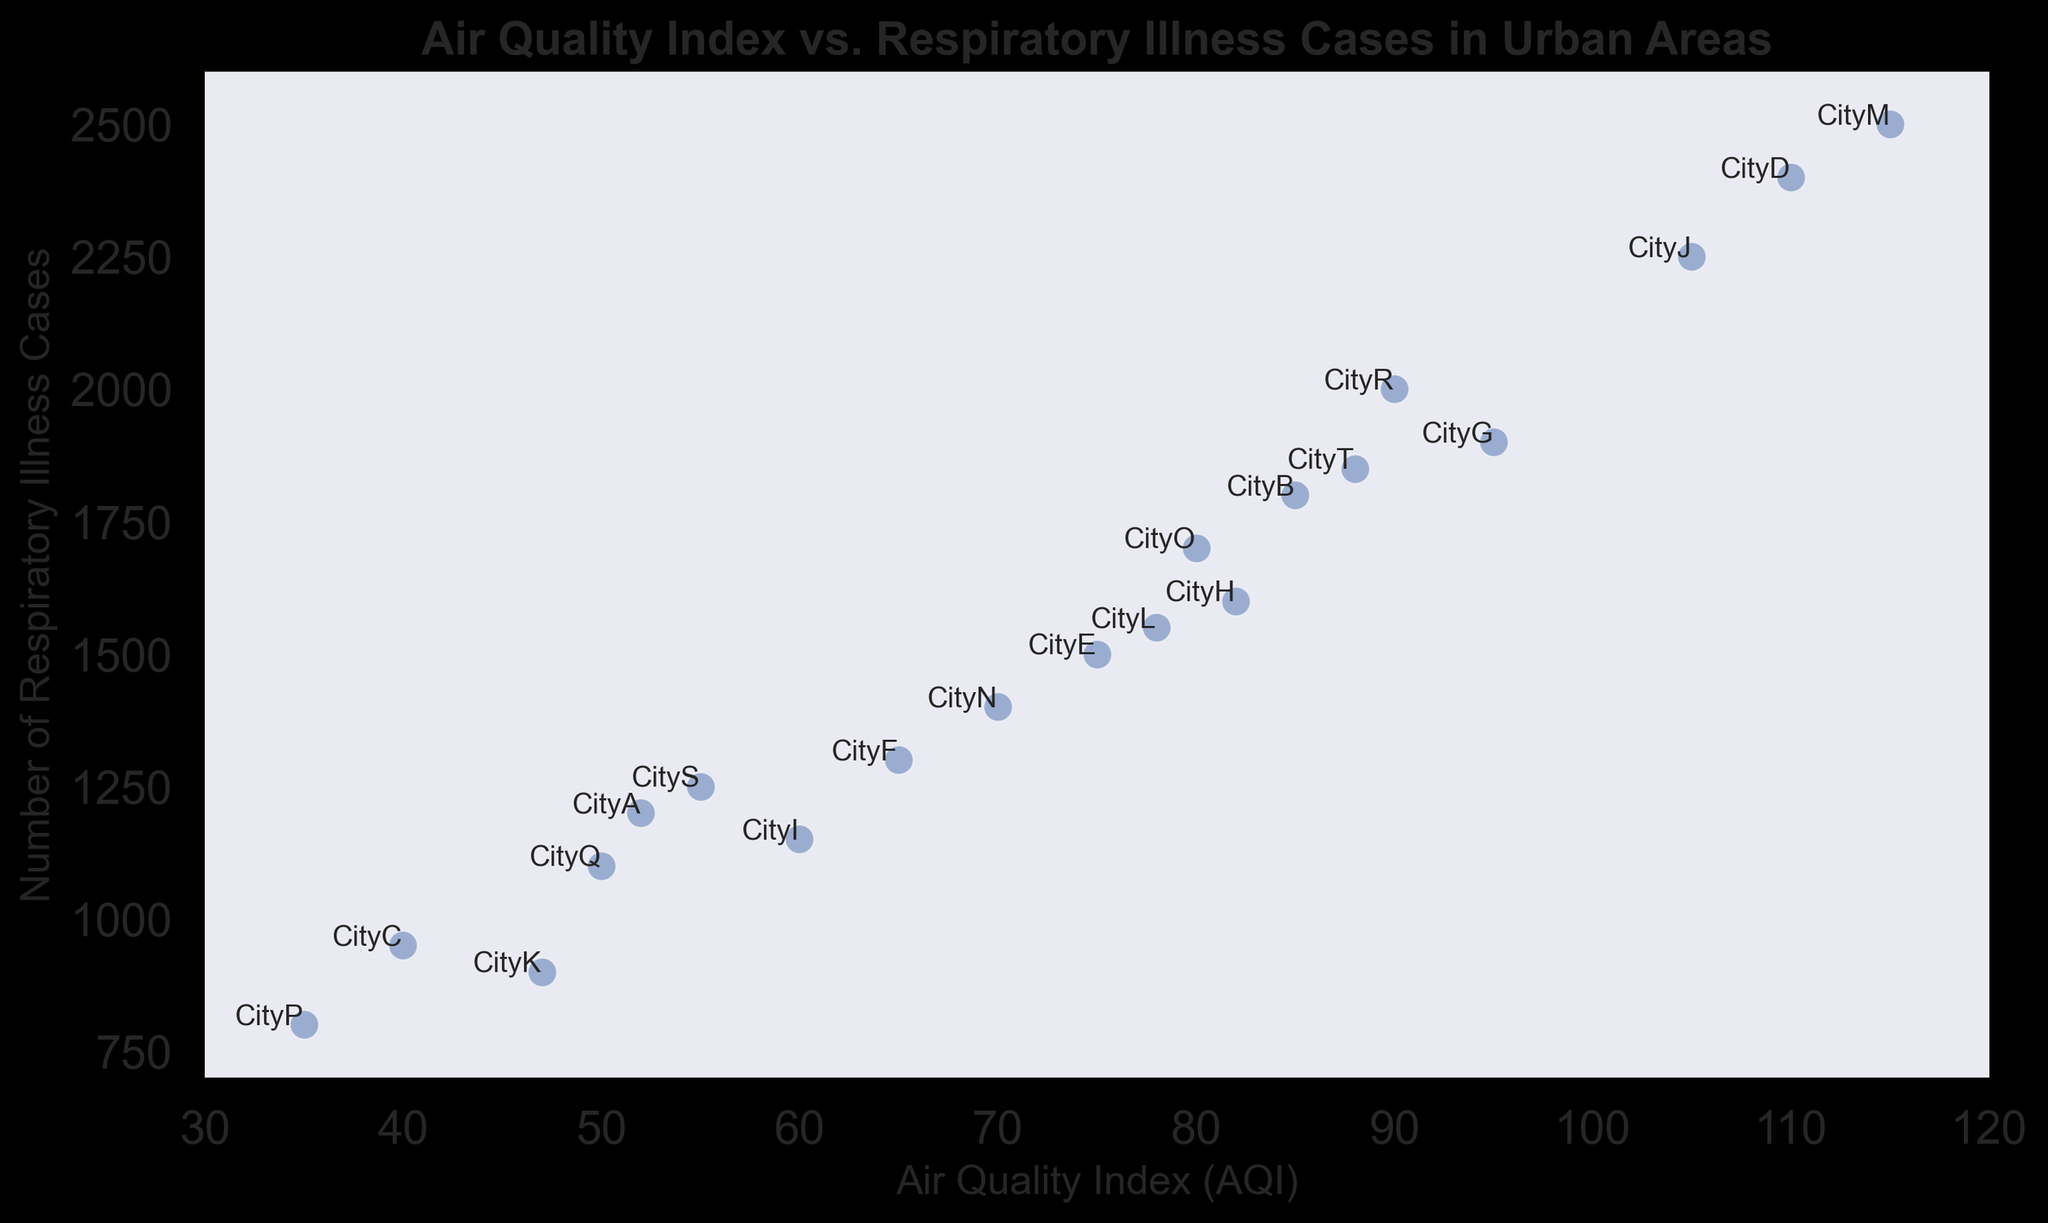What is the Air Quality Index (AQI) of CityD? Locate CityD on the scatter plot and see that its corresponding AQI value is indicated on the x-axis.
Answer: 110 Which city has the highest number of respiratory illness cases? Identify the data point with the greatest y-axis value. The point labeled "CityM" reaches the highest value, indicating 2500 cases.
Answer: CityM Compare the AQI of CityA and CityB. Which city has a higher AQI? Check the x-axis values for CityA and CityB. CityB has an AQI of 85, and CityA has an AQI of 52. Therefore, CityB has a higher AQI.
Answer: CityB What is the average number of respiratory illness cases for the cities with AQI greater than 100? Identify cities with AQI values greater than 100 (CityD and CityM). Calculate the average of their respiratory illness cases: (2400 + 2500) / 2 = 2450.
Answer: 2450 Which cities have an AQI below 50? Locate the cities on the x-axis with AQI values below 50: CityC (40), CityK (47), CityP (35), and CityQ (50).
Answer: CityC, CityK, CityP Is there a general trend between AQI and respiratory illness cases? Observe the scatter plot points' positions. Generally, as AQI increases along the x-axis, the number of respiratory illness cases also increases along the y-axis, indicating a positive correlation.
Answer: Yes Which city has roughly an AQI of 78? Find the point on the scatter plot where the AQI is 78 on the x-axis. The nearby point is labeled "CityL," indicating that its AQI is 78.
Answer: CityL By how much do respiratory illness cases increase from CityG to CityR? Find the y-values for CityG and CityR, which are 1900 and 2000, respectively. Subtract to find the difference: 2000 - 1900 = 100.
Answer: 100 What is the difference in AQI between CityF and CityJ? Locate the AQI values for CityF (65) and CityJ (105). Subtract to find the difference: 105 - 65 = 40.
Answer: 40 